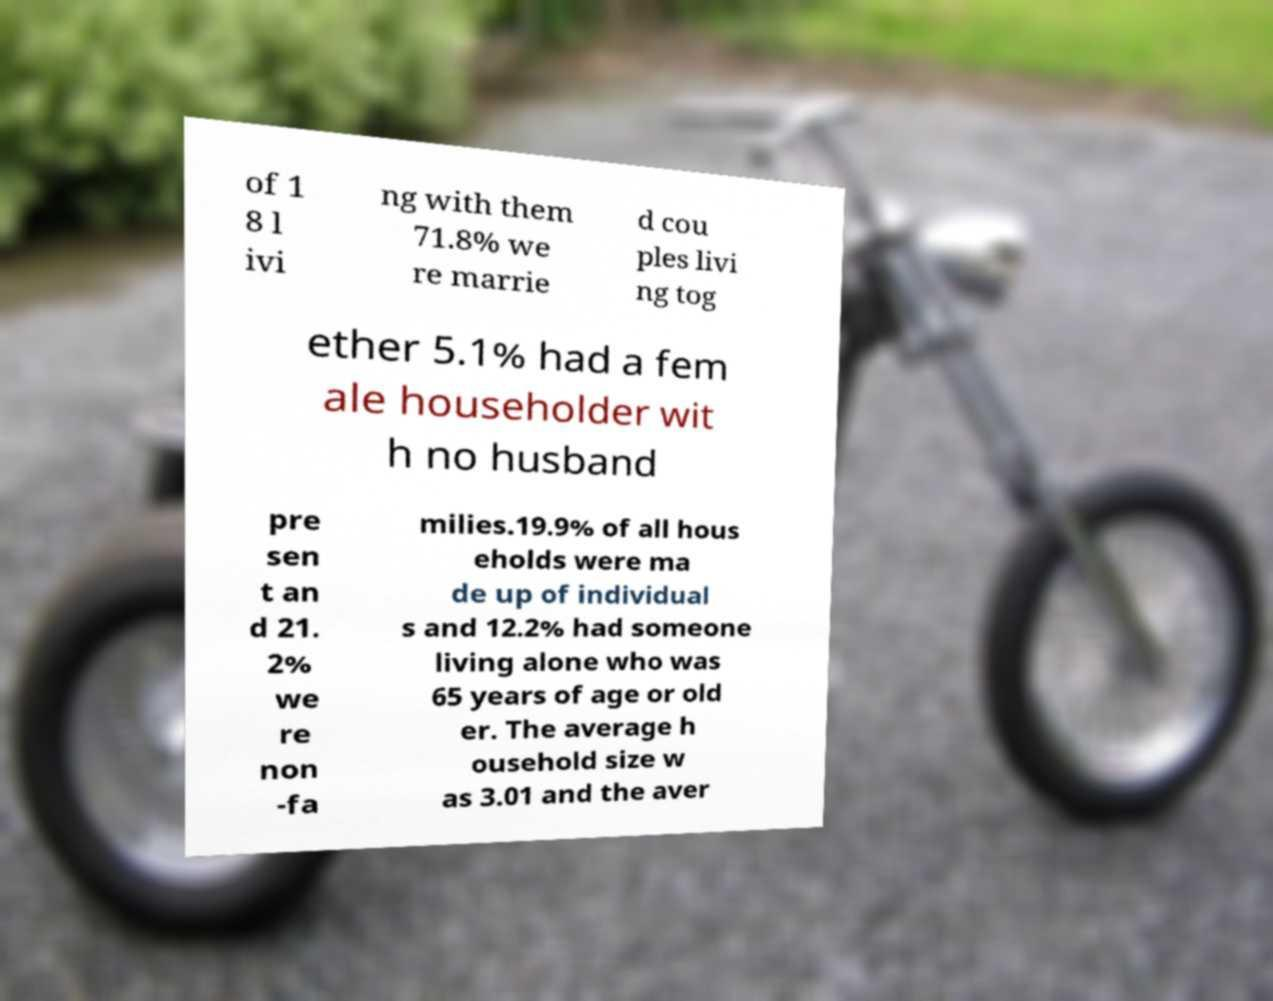Please read and relay the text visible in this image. What does it say? of 1 8 l ivi ng with them 71.8% we re marrie d cou ples livi ng tog ether 5.1% had a fem ale householder wit h no husband pre sen t an d 21. 2% we re non -fa milies.19.9% of all hous eholds were ma de up of individual s and 12.2% had someone living alone who was 65 years of age or old er. The average h ousehold size w as 3.01 and the aver 